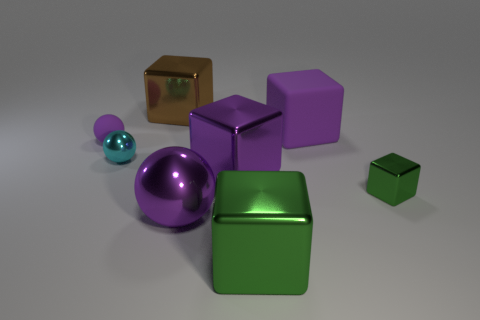There is a matte object that is left of the thing that is in front of the big purple metallic object in front of the big purple metal block; what size is it?
Your response must be concise. Small. How many objects are either metallic blocks that are in front of the small cyan thing or large purple things behind the rubber sphere?
Offer a terse response. 4. The brown shiny thing is what shape?
Make the answer very short. Cube. What number of other things are the same material as the tiny cube?
Keep it short and to the point. 5. The matte thing that is the same shape as the tiny green metal object is what size?
Provide a short and direct response. Large. What is the material of the big purple block right of the big metallic block that is in front of the metal sphere on the right side of the big brown block?
Your response must be concise. Rubber. Are any large purple matte balls visible?
Your answer should be very brief. No. There is a matte cube; is its color the same as the large metallic ball that is to the right of the tiny cyan thing?
Your response must be concise. Yes. What is the color of the small metallic ball?
Offer a very short reply. Cyan. What color is the other large rubber thing that is the same shape as the brown thing?
Offer a very short reply. Purple. 